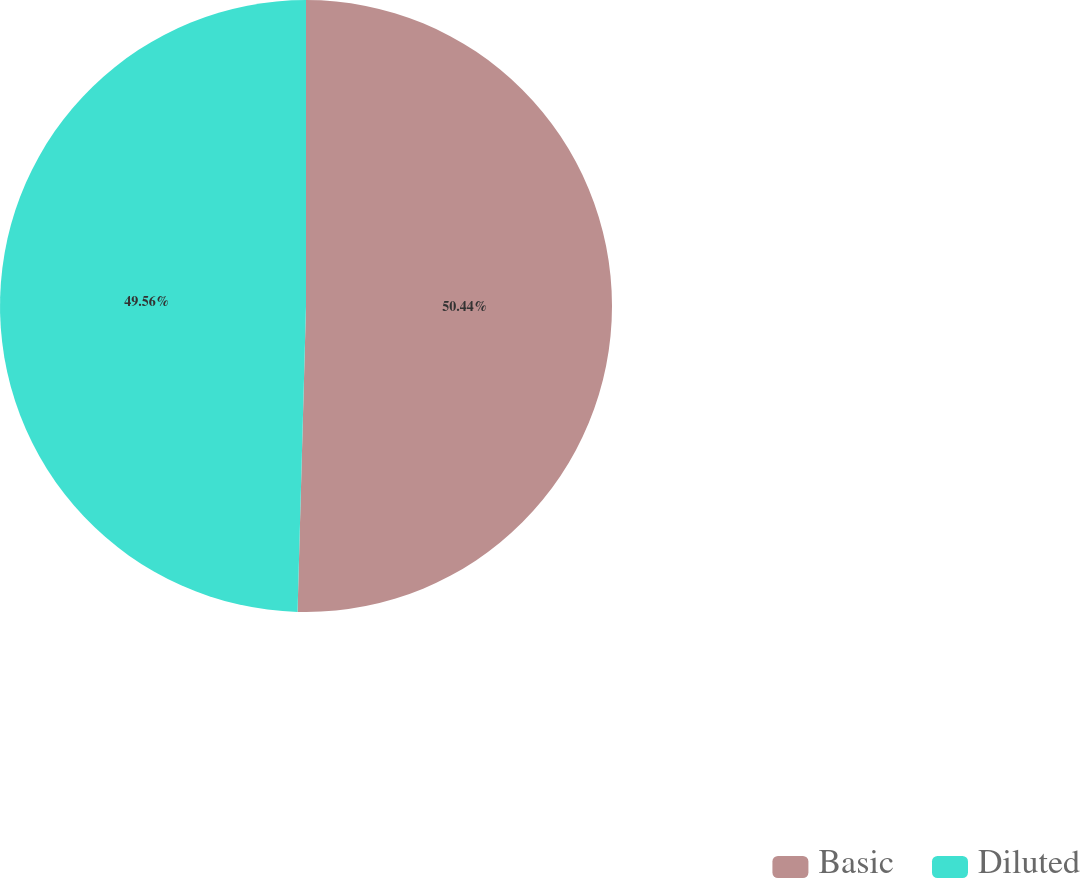<chart> <loc_0><loc_0><loc_500><loc_500><pie_chart><fcel>Basic<fcel>Diluted<nl><fcel>50.44%<fcel>49.56%<nl></chart> 